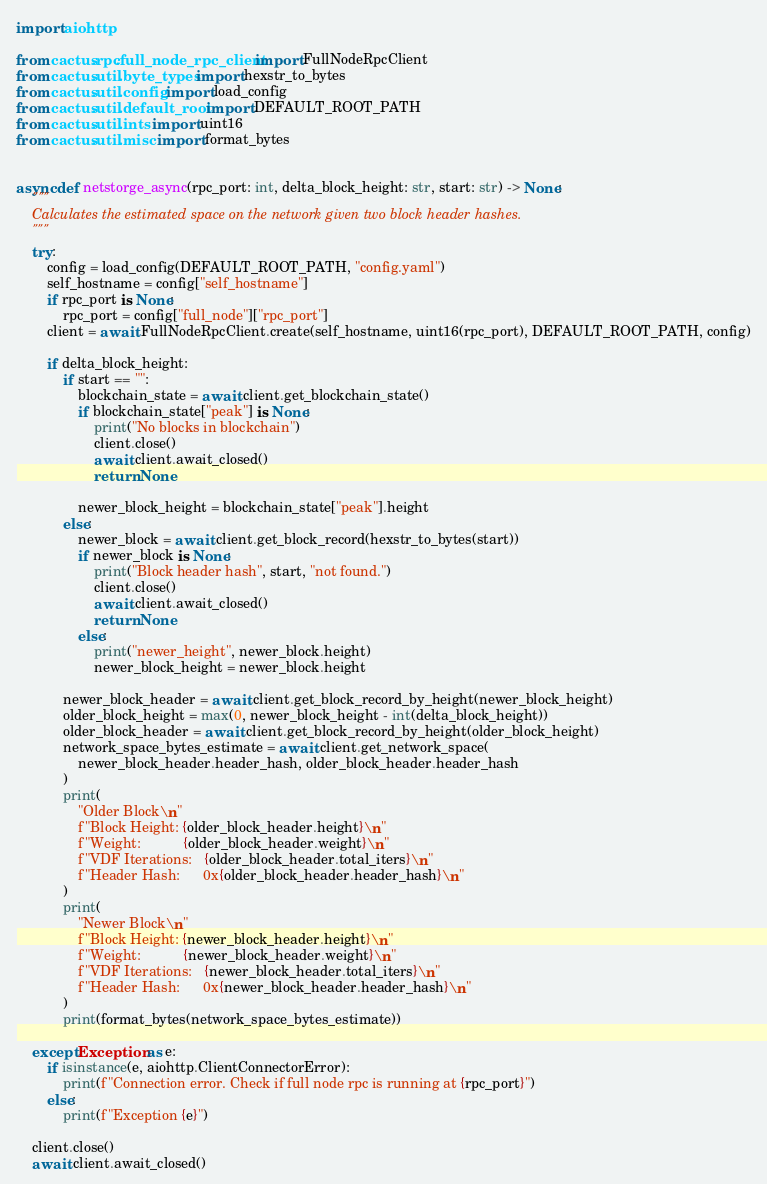<code> <loc_0><loc_0><loc_500><loc_500><_Python_>import aiohttp

from cactus.rpc.full_node_rpc_client import FullNodeRpcClient
from cactus.util.byte_types import hexstr_to_bytes
from cactus.util.config import load_config
from cactus.util.default_root import DEFAULT_ROOT_PATH
from cactus.util.ints import uint16
from cactus.util.misc import format_bytes


async def netstorge_async(rpc_port: int, delta_block_height: str, start: str) -> None:
    """
    Calculates the estimated space on the network given two block header hashes.
    """
    try:
        config = load_config(DEFAULT_ROOT_PATH, "config.yaml")
        self_hostname = config["self_hostname"]
        if rpc_port is None:
            rpc_port = config["full_node"]["rpc_port"]
        client = await FullNodeRpcClient.create(self_hostname, uint16(rpc_port), DEFAULT_ROOT_PATH, config)

        if delta_block_height:
            if start == "":
                blockchain_state = await client.get_blockchain_state()
                if blockchain_state["peak"] is None:
                    print("No blocks in blockchain")
                    client.close()
                    await client.await_closed()
                    return None

                newer_block_height = blockchain_state["peak"].height
            else:
                newer_block = await client.get_block_record(hexstr_to_bytes(start))
                if newer_block is None:
                    print("Block header hash", start, "not found.")
                    client.close()
                    await client.await_closed()
                    return None
                else:
                    print("newer_height", newer_block.height)
                    newer_block_height = newer_block.height

            newer_block_header = await client.get_block_record_by_height(newer_block_height)
            older_block_height = max(0, newer_block_height - int(delta_block_height))
            older_block_header = await client.get_block_record_by_height(older_block_height)
            network_space_bytes_estimate = await client.get_network_space(
                newer_block_header.header_hash, older_block_header.header_hash
            )
            print(
                "Older Block\n"
                f"Block Height: {older_block_header.height}\n"
                f"Weight:           {older_block_header.weight}\n"
                f"VDF Iterations:   {older_block_header.total_iters}\n"
                f"Header Hash:      0x{older_block_header.header_hash}\n"
            )
            print(
                "Newer Block\n"
                f"Block Height: {newer_block_header.height}\n"
                f"Weight:           {newer_block_header.weight}\n"
                f"VDF Iterations:   {newer_block_header.total_iters}\n"
                f"Header Hash:      0x{newer_block_header.header_hash}\n"
            )
            print(format_bytes(network_space_bytes_estimate))

    except Exception as e:
        if isinstance(e, aiohttp.ClientConnectorError):
            print(f"Connection error. Check if full node rpc is running at {rpc_port}")
        else:
            print(f"Exception {e}")

    client.close()
    await client.await_closed()
</code> 